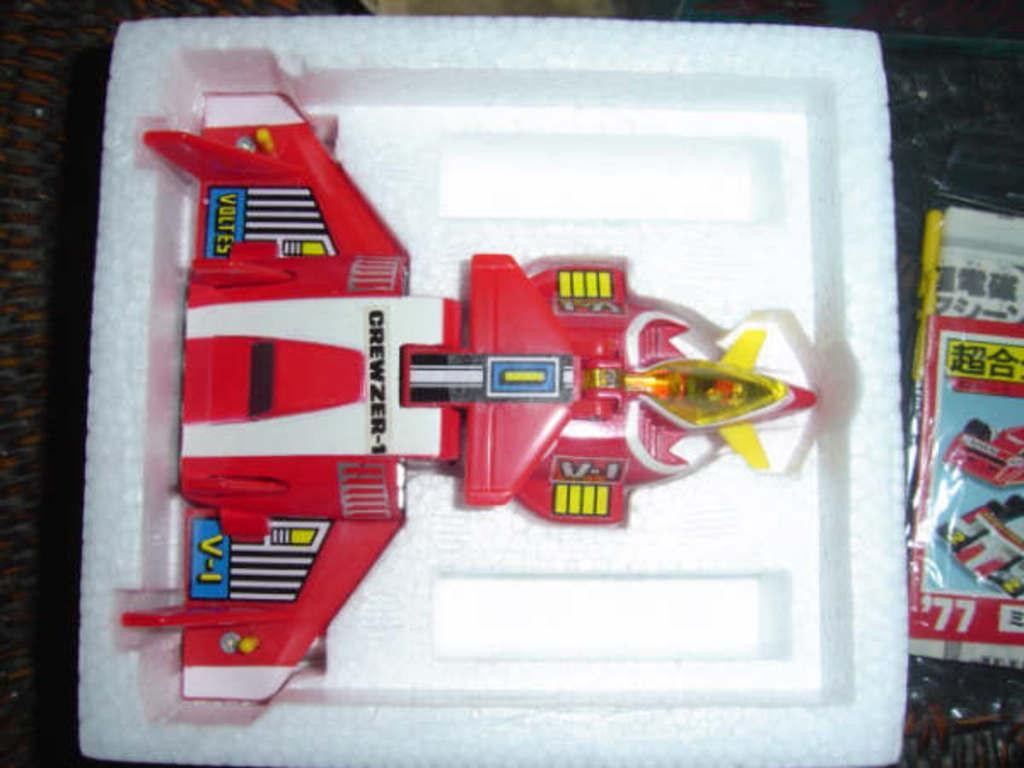Can you describe this image briefly? In this picture we can see a toy placed on a thermocol box, plastic cover with a poster and these two are placed on a platform. 